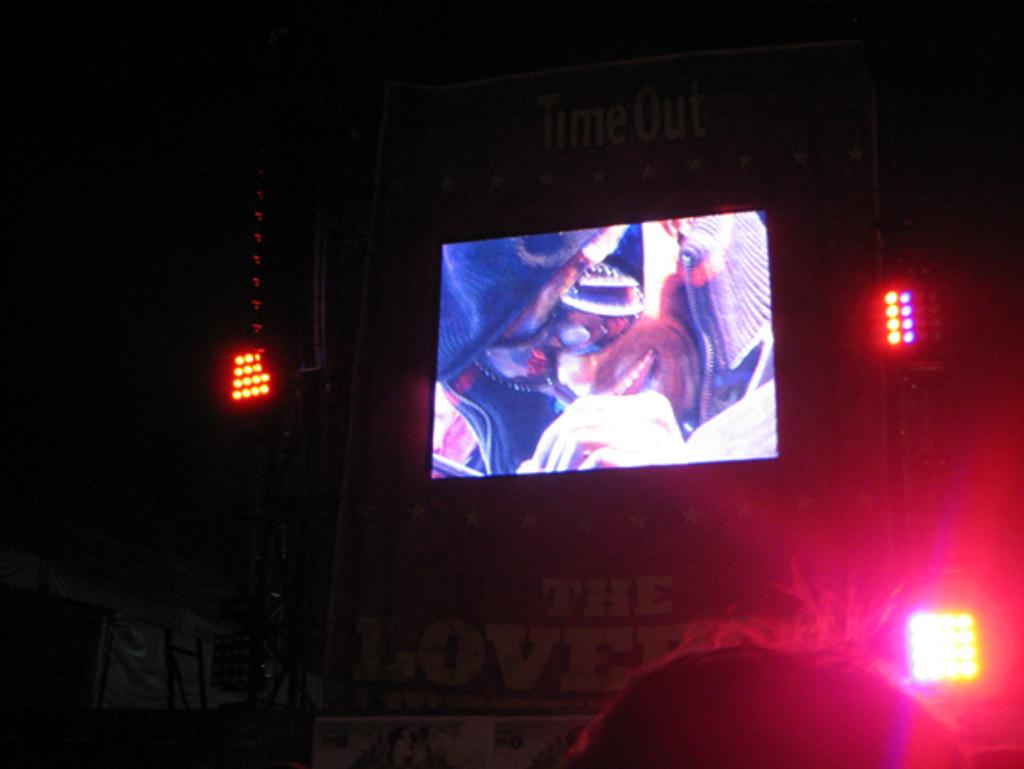What is the general lighting condition in the image? The image is taken in a dark environment. What is the main object in the image? There is a projector screen in the image. What type of lighting is present in the image? Show lights are visible in the image. What additional feature can be seen in the image? There is a banner in the image. How many caves are visible in the image? There are no caves present in the image. What type of hands are holding the banner in the image? There are no hands visible in the image; the banner is not being held by any hands. 